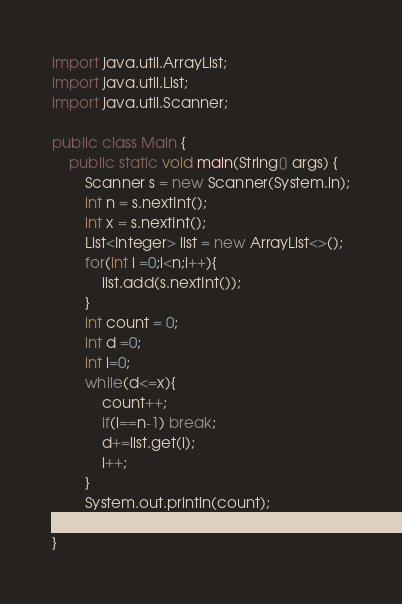Convert code to text. <code><loc_0><loc_0><loc_500><loc_500><_Java_>
import java.util.ArrayList;
import java.util.List;
import java.util.Scanner;

public class Main {
    public static void main(String[] args) {
        Scanner s = new Scanner(System.in);
        int n = s.nextInt();
        int x = s.nextInt();
        List<Integer> list = new ArrayList<>();
        for(int i =0;i<n;i++){
            list.add(s.nextInt());
        }
        int count = 0;
        int d =0;
        int i=0;
        while(d<=x){
            count++;
            if(i==n-1) break;
            d+=list.get(i);
            i++;
        }
        System.out.println(count);
    }
}
</code> 